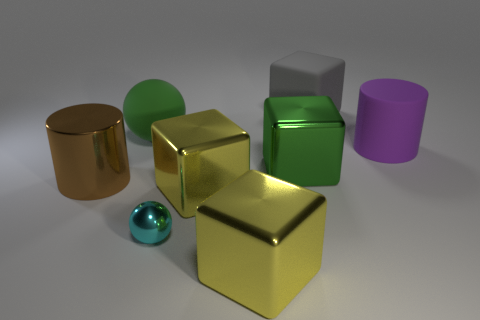Subtract all red cylinders. How many yellow blocks are left? 2 Subtract all large shiny cubes. How many cubes are left? 1 Subtract all green blocks. How many blocks are left? 3 Subtract all red blocks. Subtract all cyan balls. How many blocks are left? 4 Add 1 big rubber cylinders. How many objects exist? 9 Subtract all spheres. How many objects are left? 6 Subtract all gray matte blocks. Subtract all green metal blocks. How many objects are left? 6 Add 4 spheres. How many spheres are left? 6 Add 1 tiny green cubes. How many tiny green cubes exist? 1 Subtract 1 green blocks. How many objects are left? 7 